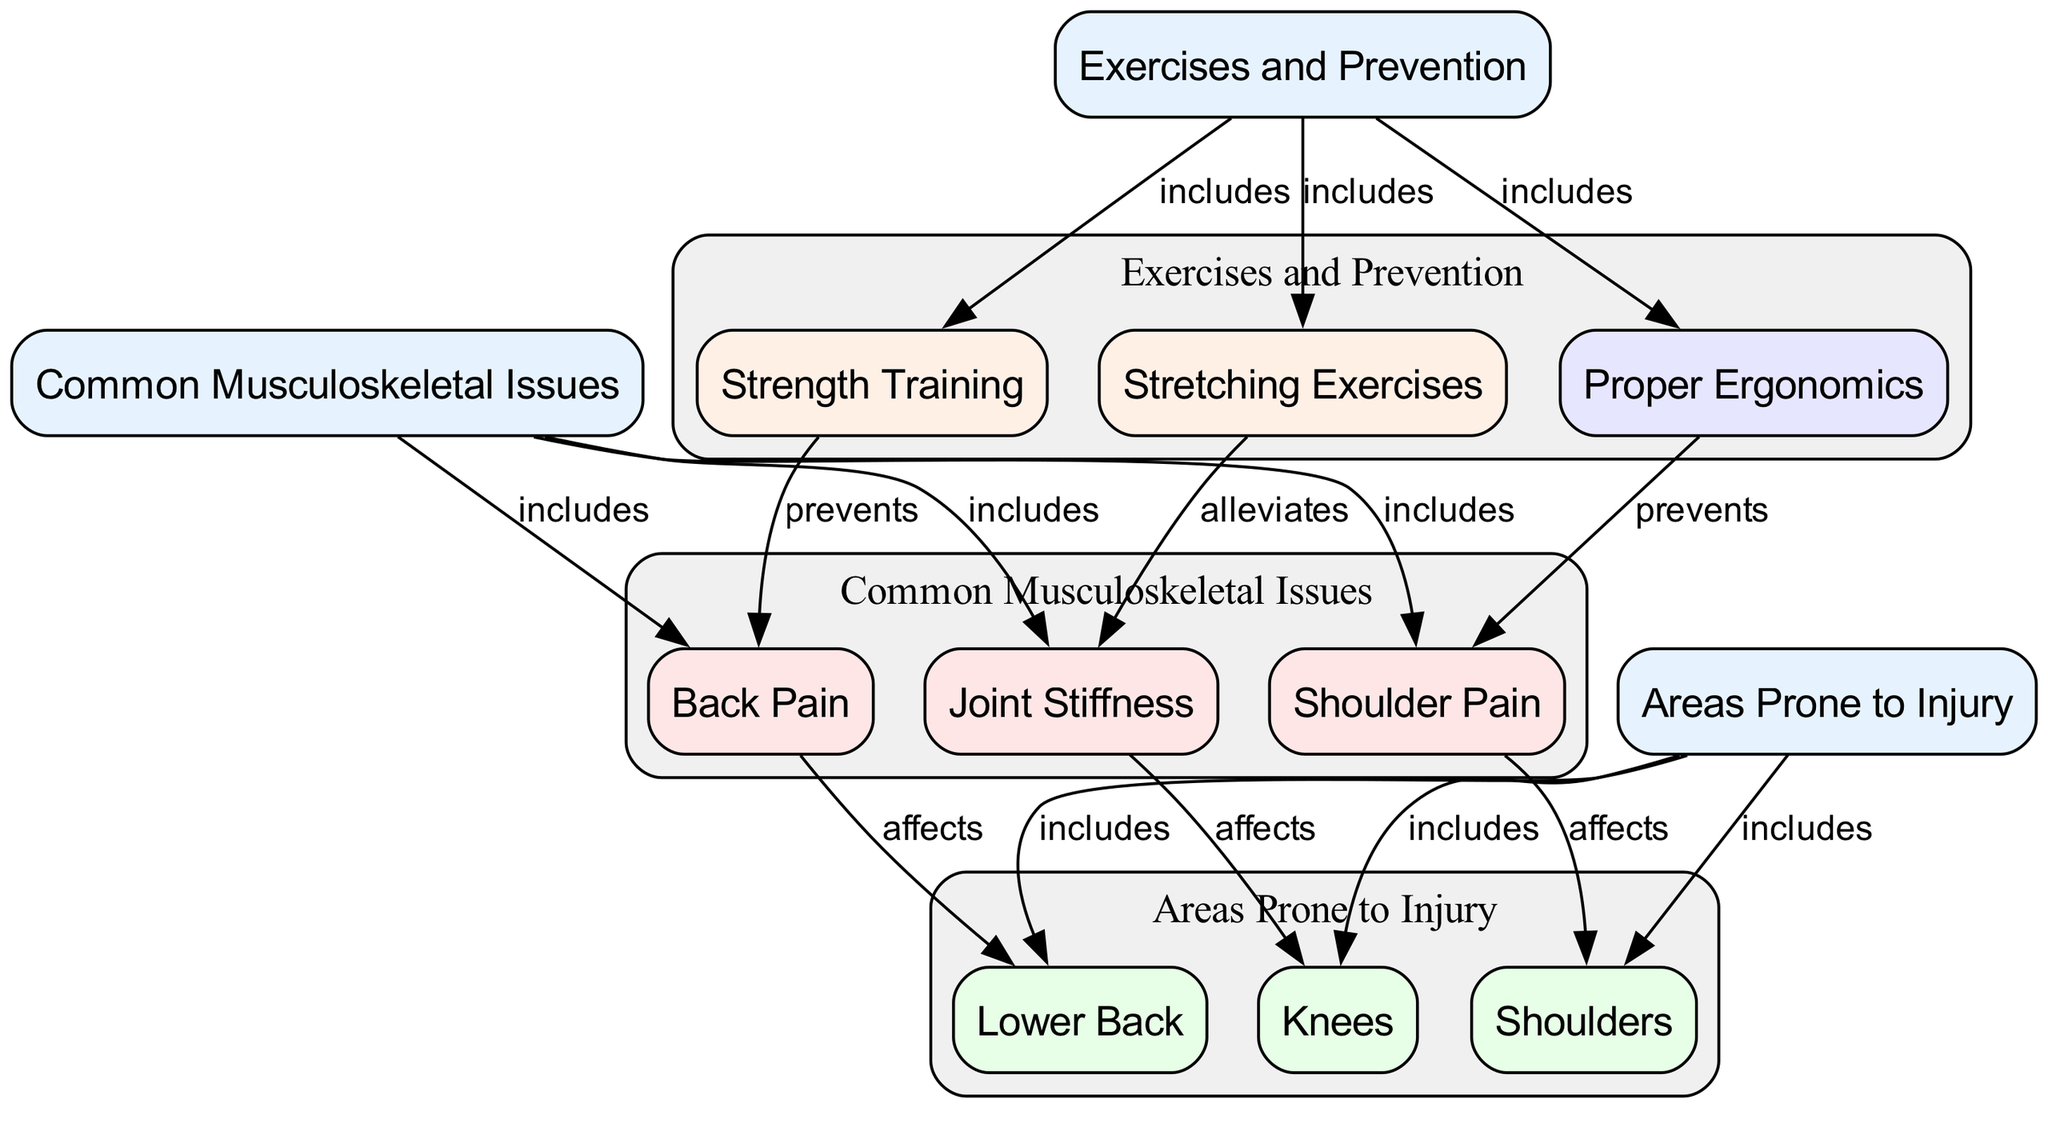What are the common musculoskeletal issues? The diagram indicates three common musculoskeletal issues under the category "Common Musculoskeletal Issues": Back Pain, Shoulder Pain, and Joint Stiffness.
Answer: Back Pain, Shoulder Pain, Joint Stiffness Which area is affected by back pain? The diagram shows that "Back Pain" specifically affects the "Lower Back" area, establishing a direct connection between them in the visual representation.
Answer: Lower Back How many areas are prone to injury? The diagram lists three areas under the "Areas Prone to Injury" category: Lower Back, Shoulders, and Knees, confirming that there are a total of three areas.
Answer: 3 What do stretching exercises alleviate? According to the diagram, stretching exercises have a direct relationship with "Joint Stiffness," indicating that they alleviate this specific issue.
Answer: Joint Stiffness Which prevention method prevents shoulder pain? The diagram illustrates that "Proper Ergonomics" prevents "Shoulder Pain," showing a clear link between these two components in the diagram.
Answer: Proper Ergonomics What type of exercise helps prevent back pain? The diagram specifies that "Strength Training" is an exercise that prevents back pain, highlighted by the relationship indicated in the diagram.
Answer: Strength Training What is included in the exercises and prevention category? The diagram mentions three components under the "Exercises and Prevention" category: Stretching, Strength Training, and Proper Ergonomics, all contributing to musculoskeletal health.
Answer: Stretching, Strength Training, Proper Ergonomics Which area is included in the areas prone to injury? The diagram highlights three areas under "Areas Prone to Injury," which are Lower Back, Shoulders, and Knees, directly stating their inclusion.
Answer: Lower Back, Shoulders, Knees What three issues are included under common musculoskeletal issues? The diagram clearly enumerates three specific issues under "Common Musculoskeletal Issues": Back Pain, Shoulder Pain, and Joint Stiffness, confirming their inclusion.
Answer: Back Pain, Shoulder Pain, Joint Stiffness 